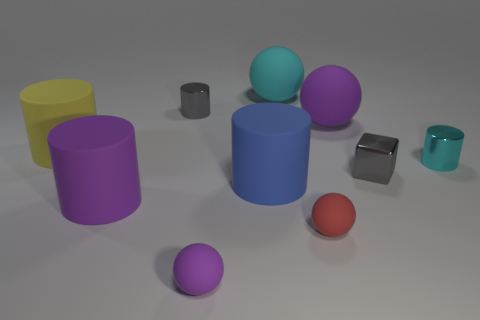What is the material of the large purple object that is on the right side of the big thing that is in front of the blue cylinder?
Keep it short and to the point. Rubber. How many objects are large blue objects or tiny shiny objects?
Your answer should be very brief. 4. What is the size of the metal object that is the same color as the tiny block?
Offer a terse response. Small. Are there fewer shiny cylinders than large cyan spheres?
Keep it short and to the point. No. There is a blue cylinder that is made of the same material as the yellow cylinder; what size is it?
Your answer should be very brief. Large. How big is the blue cylinder?
Offer a very short reply. Large. What is the shape of the red matte thing?
Provide a succinct answer. Sphere. Does the tiny shiny cylinder that is on the left side of the gray cube have the same color as the small block?
Provide a short and direct response. Yes. The purple rubber object that is the same shape as the small cyan metallic object is what size?
Provide a short and direct response. Large. Is there any other thing that is made of the same material as the purple cylinder?
Your response must be concise. Yes. 